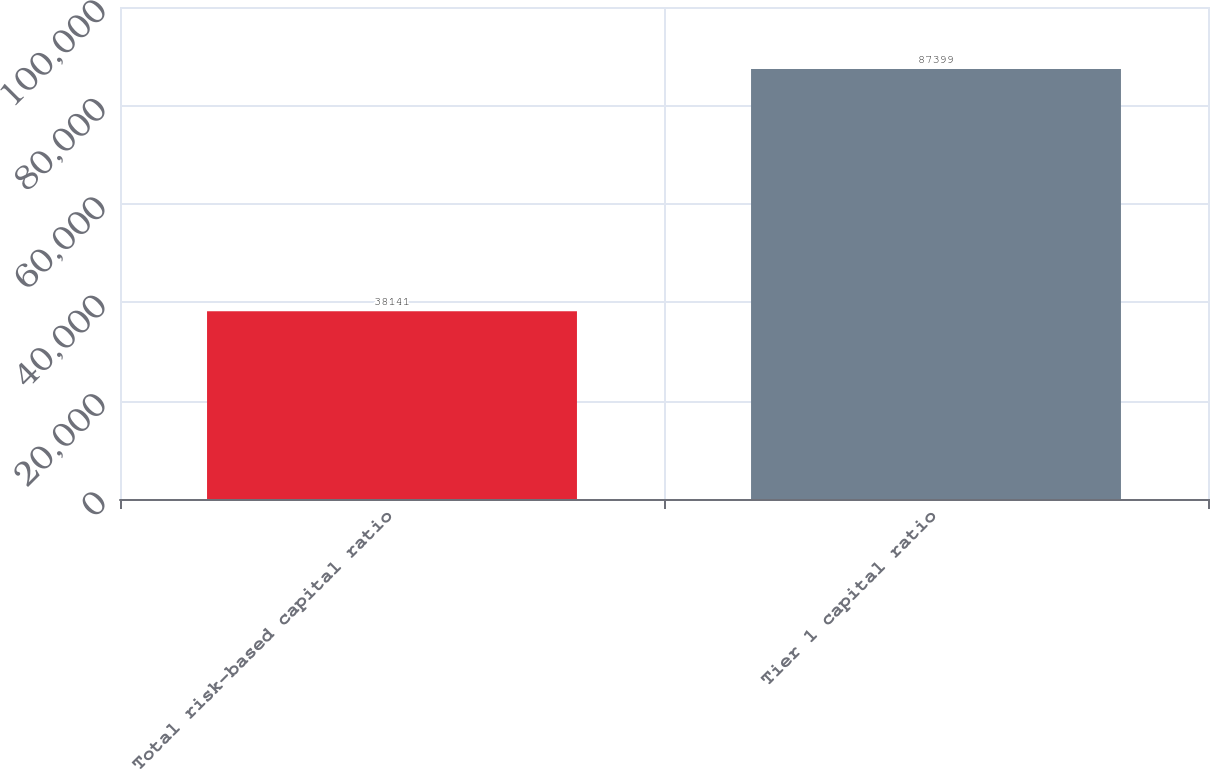Convert chart to OTSL. <chart><loc_0><loc_0><loc_500><loc_500><bar_chart><fcel>Total risk-based capital ratio<fcel>Tier 1 capital ratio<nl><fcel>38141<fcel>87399<nl></chart> 